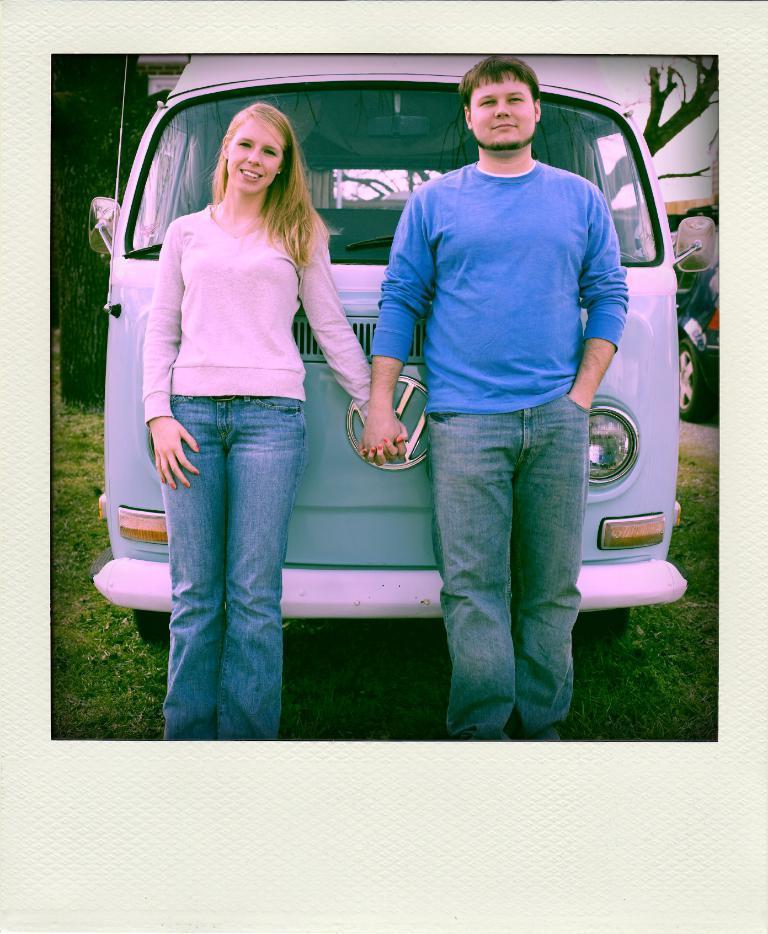Describe this image in one or two sentences. This is an edited image with the borders. On the right there is a man wearing blue color t-shirt and we can see a woman wearing pink color t-shirt and both of them are standing on the ground. In the background we can see the vehicles and we can see the sky, trees and the grass. 